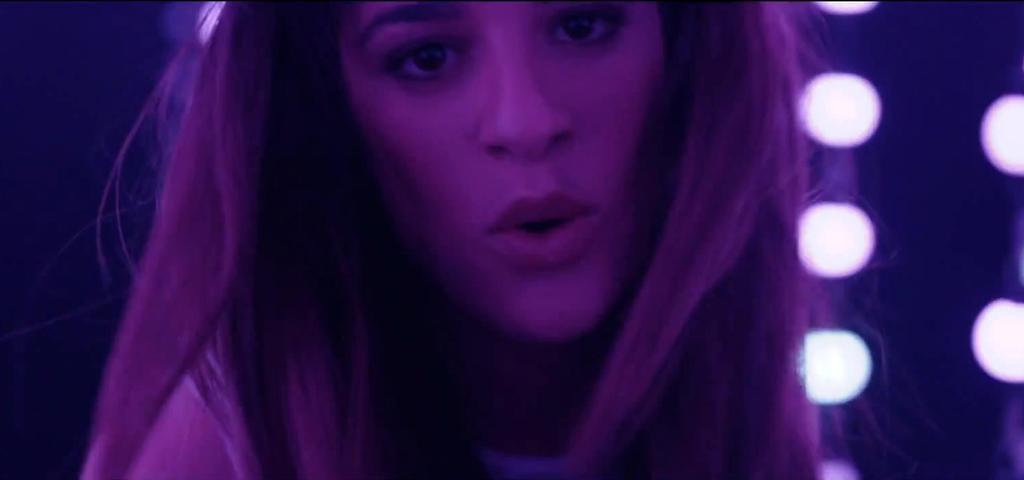How would you summarize this image in a sentence or two? In this image a lady is there in the background there are lights. 